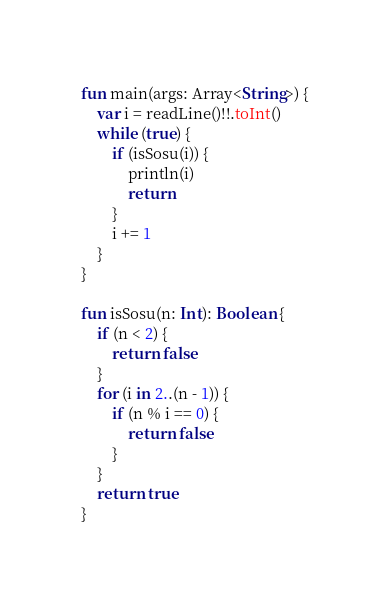<code> <loc_0><loc_0><loc_500><loc_500><_Kotlin_>fun main(args: Array<String>) {
    var i = readLine()!!.toInt()
    while (true) {
        if (isSosu(i)) {
            println(i)
            return
        }
        i += 1
    }
}

fun isSosu(n: Int): Boolean {
    if (n < 2) {
        return false
    }
    for (i in 2..(n - 1)) {
        if (n % i == 0) {
            return false
        }
    }
    return true
}
</code> 